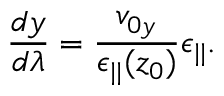<formula> <loc_0><loc_0><loc_500><loc_500>\frac { d y } { d \lambda } = \frac { v _ { 0 y } } { \epsilon _ { | | } ( z _ { 0 } ) } \epsilon _ { | | } .</formula> 